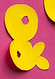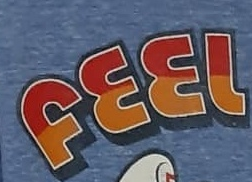What words can you see in these images in sequence, separated by a semicolon? &; FEEL 